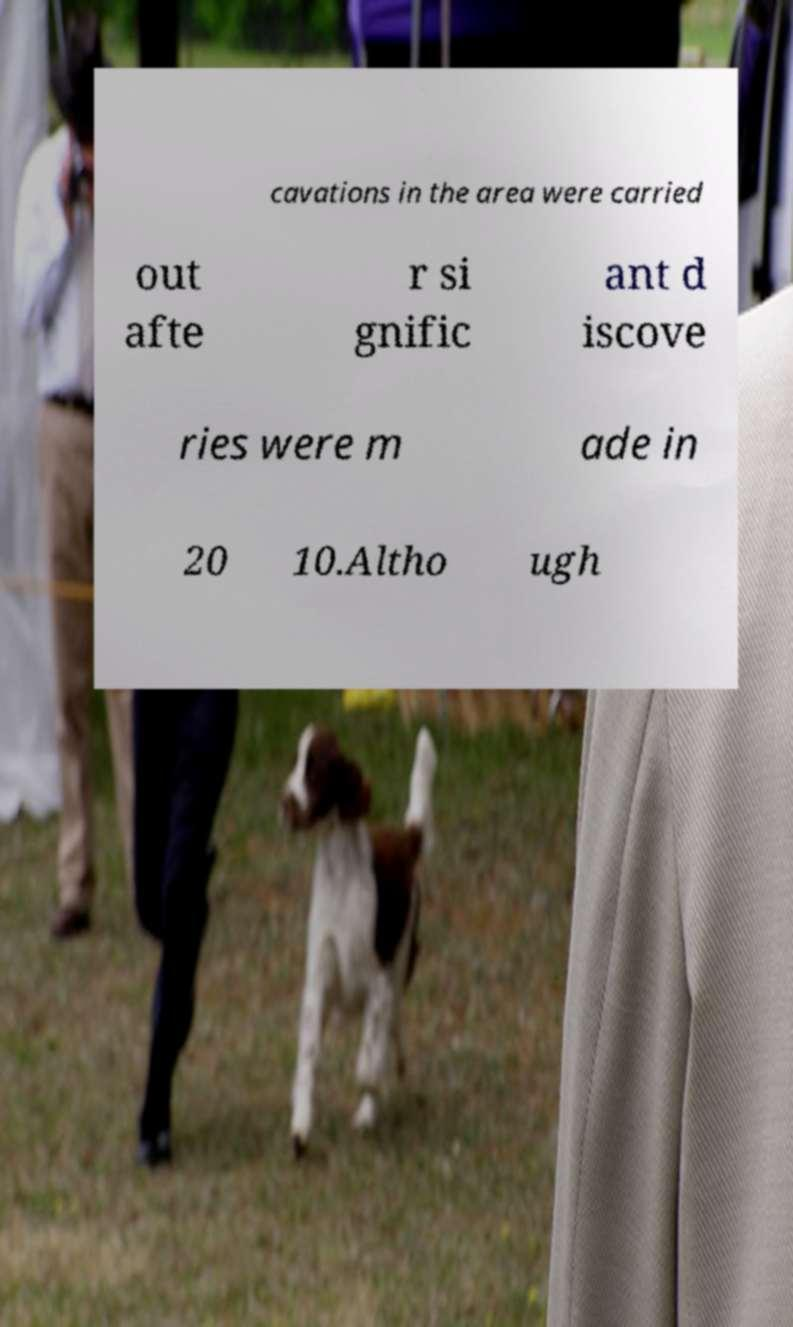For documentation purposes, I need the text within this image transcribed. Could you provide that? cavations in the area were carried out afte r si gnific ant d iscove ries were m ade in 20 10.Altho ugh 